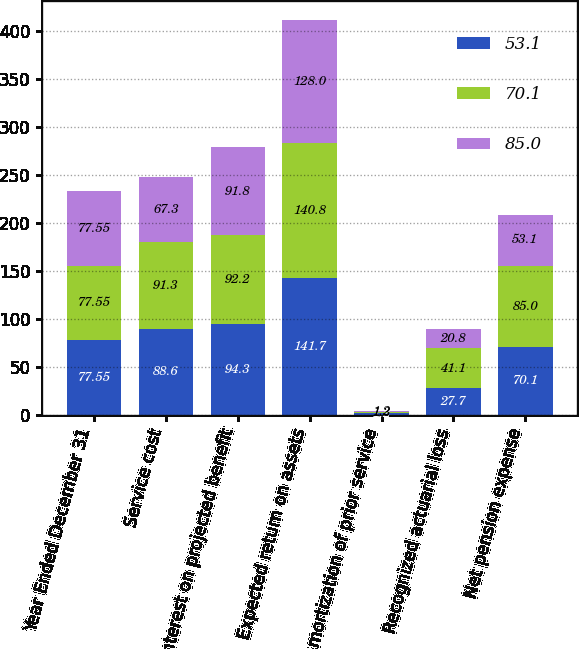Convert chart. <chart><loc_0><loc_0><loc_500><loc_500><stacked_bar_chart><ecel><fcel>Year Ended December 31<fcel>Service cost<fcel>Interest on projected benefit<fcel>Expected return on assets<fcel>Amortization of prior service<fcel>Recognized actuarial loss<fcel>Net pension expense<nl><fcel>53.1<fcel>77.55<fcel>88.6<fcel>94.3<fcel>141.7<fcel>1.2<fcel>27.7<fcel>70.1<nl><fcel>70.1<fcel>77.55<fcel>91.3<fcel>92.2<fcel>140.8<fcel>1.3<fcel>41.1<fcel>85<nl><fcel>85<fcel>77.55<fcel>67.3<fcel>91.8<fcel>128<fcel>1.2<fcel>20.8<fcel>53.1<nl></chart> 